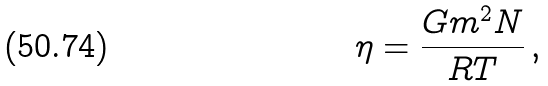Convert formula to latex. <formula><loc_0><loc_0><loc_500><loc_500>\eta = \frac { G m ^ { 2 } N } { R T } \, ,</formula> 